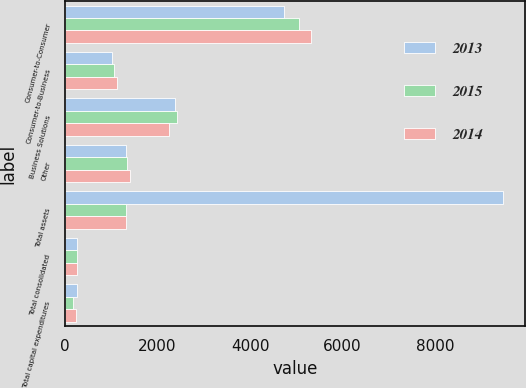Convert chart. <chart><loc_0><loc_0><loc_500><loc_500><stacked_bar_chart><ecel><fcel>Consumer-to-Consumer<fcel>Consumer-to-Business<fcel>Business Solutions<fcel>Other<fcel>Total assets<fcel>Total consolidated<fcel>Total capital expenditures<nl><fcel>2013<fcel>4738.7<fcel>1010.1<fcel>2384.4<fcel>1325.7<fcel>9458.9<fcel>270.2<fcel>266.5<nl><fcel>2015<fcel>5049.7<fcel>1060.2<fcel>2430.7<fcel>1349.8<fcel>1325.7<fcel>271.9<fcel>179<nl><fcel>2014<fcel>5321.9<fcel>1129.9<fcel>2256.4<fcel>1413.1<fcel>1325.7<fcel>262.8<fcel>241.3<nl></chart> 